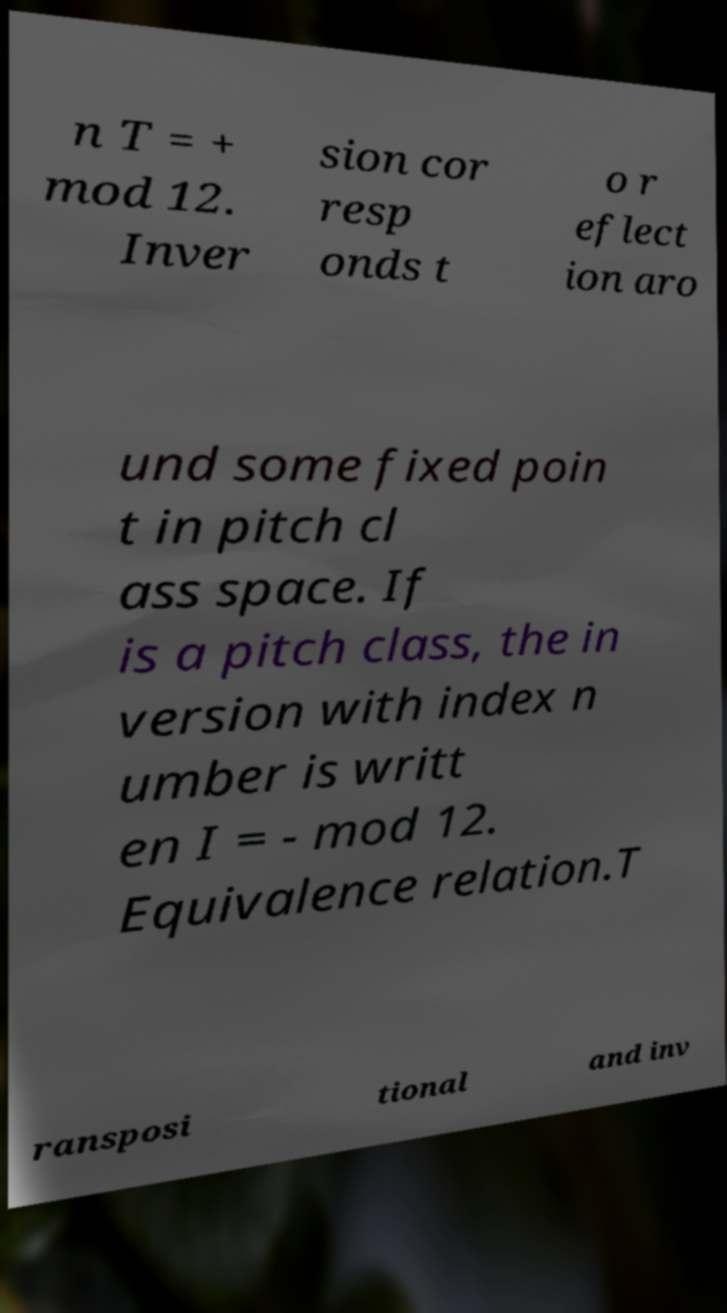Could you extract and type out the text from this image? n T = + mod 12. Inver sion cor resp onds t o r eflect ion aro und some fixed poin t in pitch cl ass space. If is a pitch class, the in version with index n umber is writt en I = - mod 12. Equivalence relation.T ransposi tional and inv 